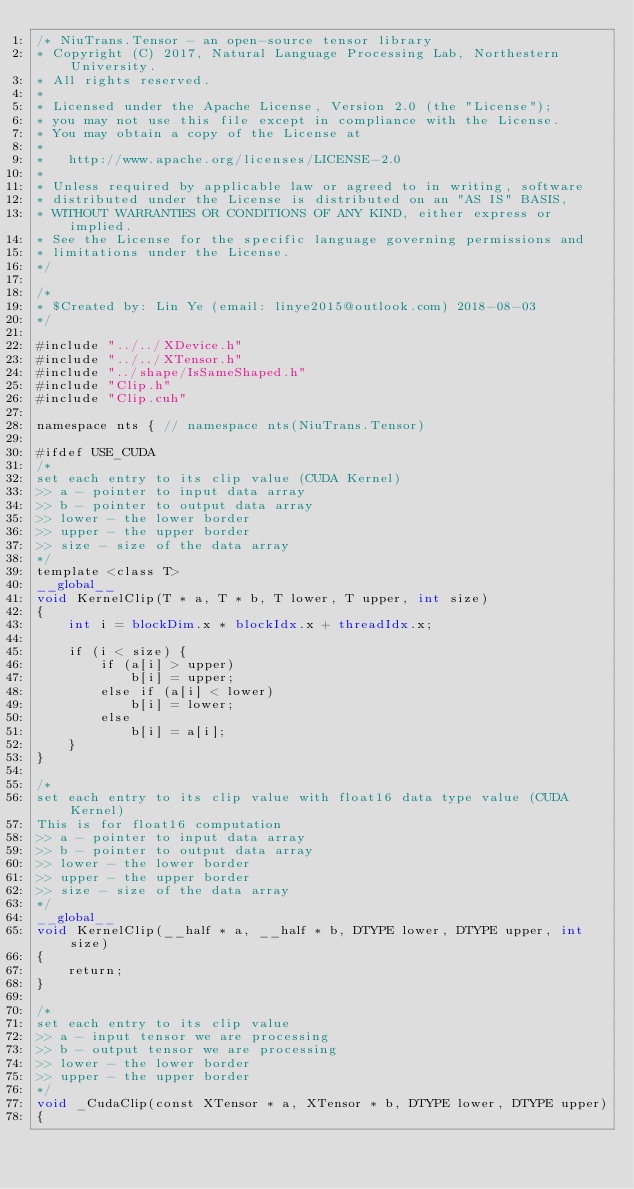Convert code to text. <code><loc_0><loc_0><loc_500><loc_500><_Cuda_>/* NiuTrans.Tensor - an open-source tensor library
* Copyright (C) 2017, Natural Language Processing Lab, Northestern University.
* All rights reserved.
*
* Licensed under the Apache License, Version 2.0 (the "License");
* you may not use this file except in compliance with the License.
* You may obtain a copy of the License at
*
*   http://www.apache.org/licenses/LICENSE-2.0
*
* Unless required by applicable law or agreed to in writing, software
* distributed under the License is distributed on an "AS IS" BASIS,
* WITHOUT WARRANTIES OR CONDITIONS OF ANY KIND, either express or implied.
* See the License for the specific language governing permissions and
* limitations under the License.
*/

/*
* $Created by: Lin Ye (email: linye2015@outlook.com) 2018-08-03
*/

#include "../../XDevice.h"
#include "../../XTensor.h"
#include "../shape/IsSameShaped.h"
#include "Clip.h"
#include "Clip.cuh"

namespace nts { // namespace nts(NiuTrans.Tensor)

#ifdef USE_CUDA
/*
set each entry to its clip value (CUDA Kernel)
>> a - pointer to input data array
>> b - pointer to output data array
>> lower - the lower border
>> upper - the upper border
>> size - size of the data array
*/
template <class T>
__global__
void KernelClip(T * a, T * b, T lower, T upper, int size)
{
    int i = blockDim.x * blockIdx.x + threadIdx.x;

    if (i < size) {
        if (a[i] > upper)
            b[i] = upper;
        else if (a[i] < lower)
            b[i] = lower;
        else
            b[i] = a[i];
    }
}

/*
set each entry to its clip value with float16 data type value (CUDA Kernel)
This is for float16 computation
>> a - pointer to input data array
>> b - pointer to output data array
>> lower - the lower border
>> upper - the upper border
>> size - size of the data array
*/
__global__
void KernelClip(__half * a, __half * b, DTYPE lower, DTYPE upper, int size)
{
    return;
}

/*
set each entry to its clip value
>> a - input tensor we are processing
>> b - output tensor we are processing
>> lower - the lower border
>> upper - the upper border
*/
void _CudaClip(const XTensor * a, XTensor * b, DTYPE lower, DTYPE upper)
{</code> 